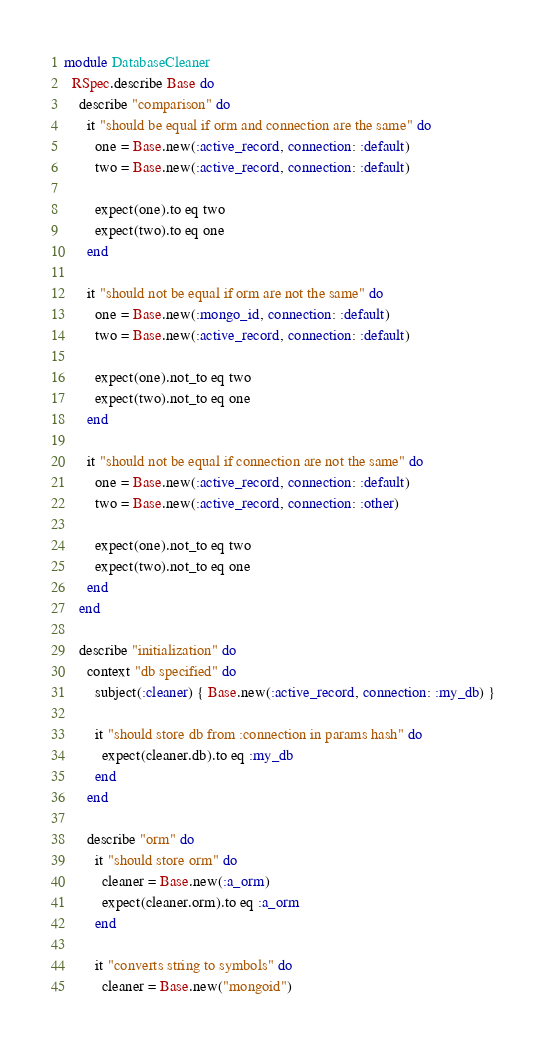Convert code to text. <code><loc_0><loc_0><loc_500><loc_500><_Ruby_>module DatabaseCleaner
  RSpec.describe Base do
    describe "comparison" do
      it "should be equal if orm and connection are the same" do
        one = Base.new(:active_record, connection: :default)
        two = Base.new(:active_record, connection: :default)

        expect(one).to eq two
        expect(two).to eq one
      end

      it "should not be equal if orm are not the same" do
        one = Base.new(:mongo_id, connection: :default)
        two = Base.new(:active_record, connection: :default)

        expect(one).not_to eq two
        expect(two).not_to eq one
      end

      it "should not be equal if connection are not the same" do
        one = Base.new(:active_record, connection: :default)
        two = Base.new(:active_record, connection: :other)

        expect(one).not_to eq two
        expect(two).not_to eq one
      end
    end

    describe "initialization" do
      context "db specified" do
        subject(:cleaner) { Base.new(:active_record, connection: :my_db) }

        it "should store db from :connection in params hash" do
          expect(cleaner.db).to eq :my_db
        end
      end

      describe "orm" do
        it "should store orm" do
          cleaner = Base.new(:a_orm)
          expect(cleaner.orm).to eq :a_orm
        end

        it "converts string to symbols" do
          cleaner = Base.new("mongoid")</code> 